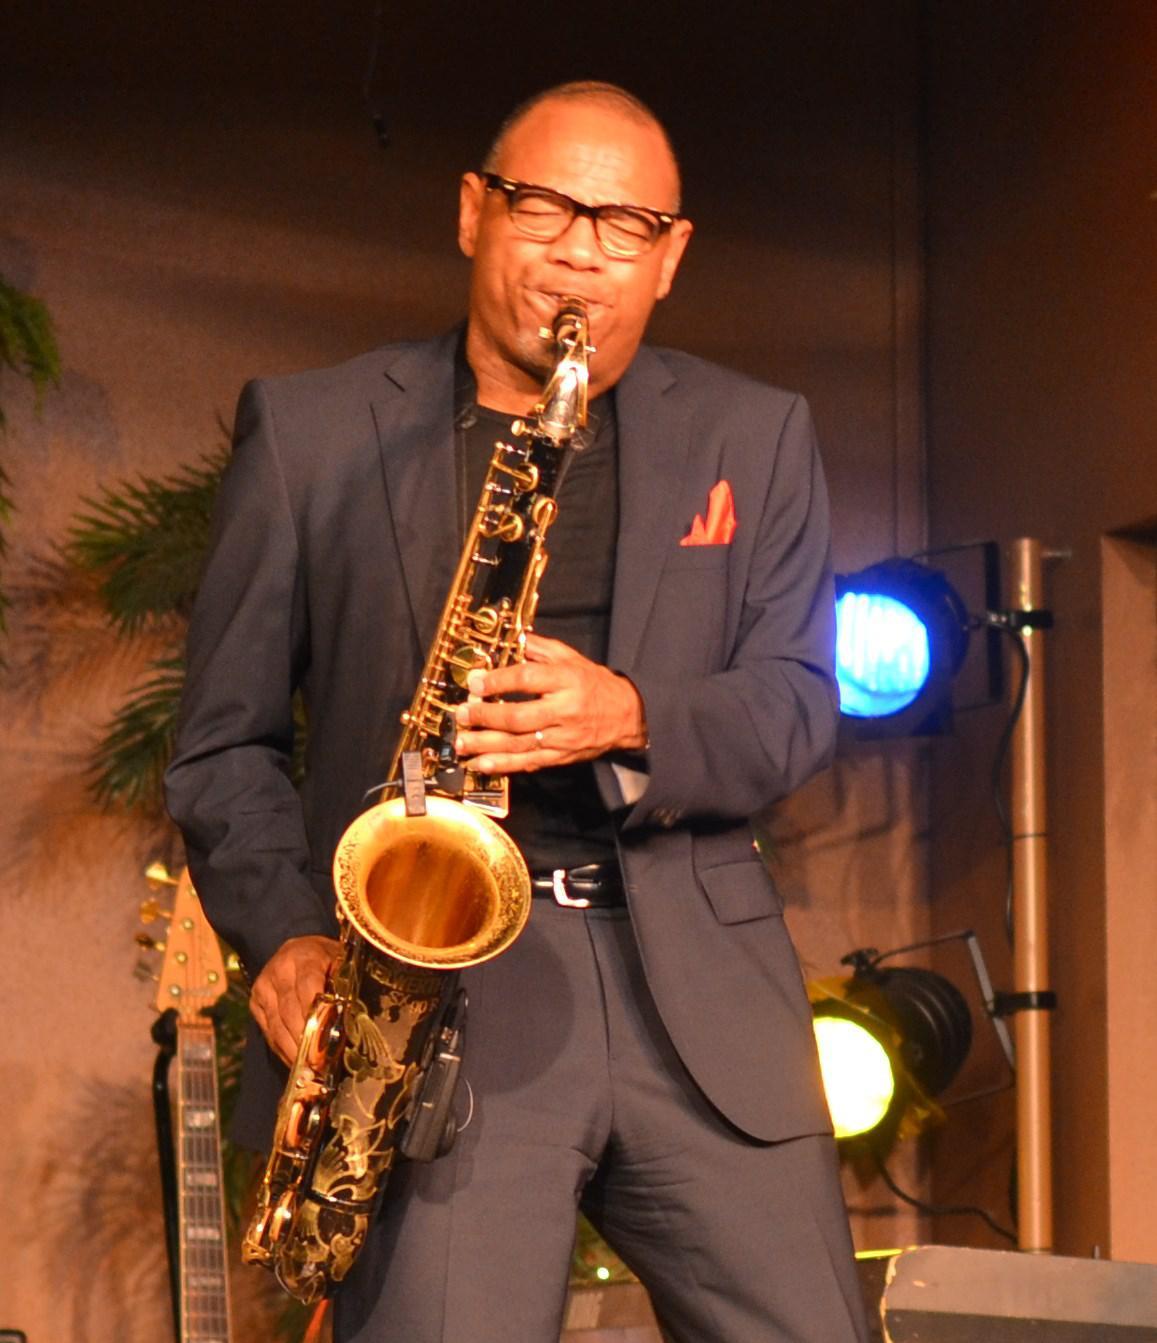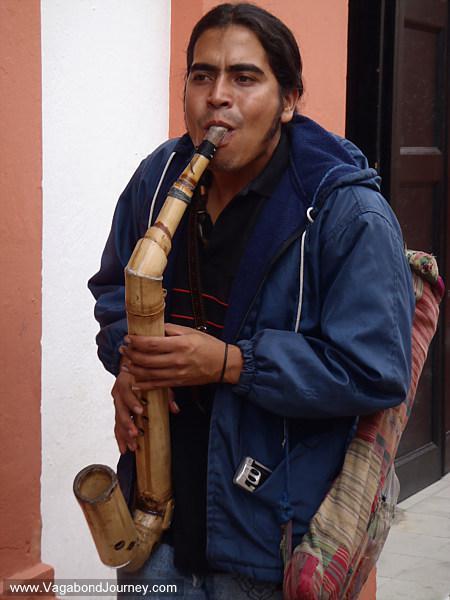The first image is the image on the left, the second image is the image on the right. For the images displayed, is the sentence "A white man is playing a saxophone in the image on the right." factually correct? Answer yes or no. No. The first image is the image on the left, the second image is the image on the right. Considering the images on both sides, is "An image shows an adult black male with shaved head, playing the saxophone while dressed all in black." valid? Answer yes or no. Yes. 